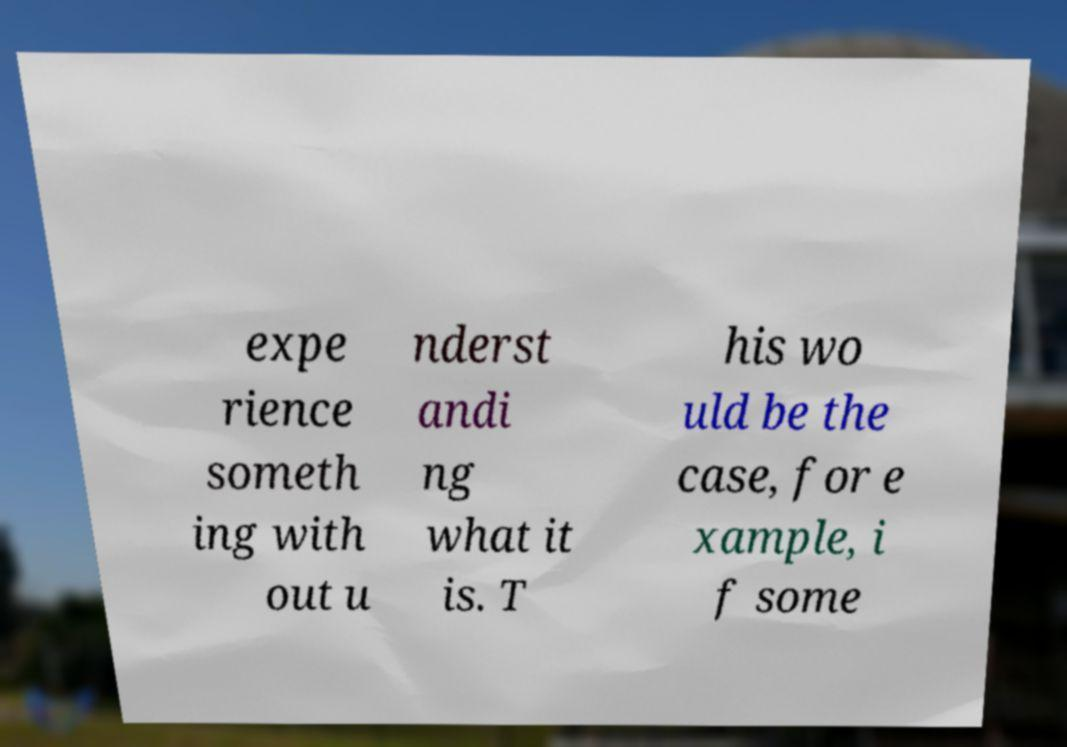Please identify and transcribe the text found in this image. expe rience someth ing with out u nderst andi ng what it is. T his wo uld be the case, for e xample, i f some 